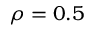Convert formula to latex. <formula><loc_0><loc_0><loc_500><loc_500>\rho = 0 . 5</formula> 